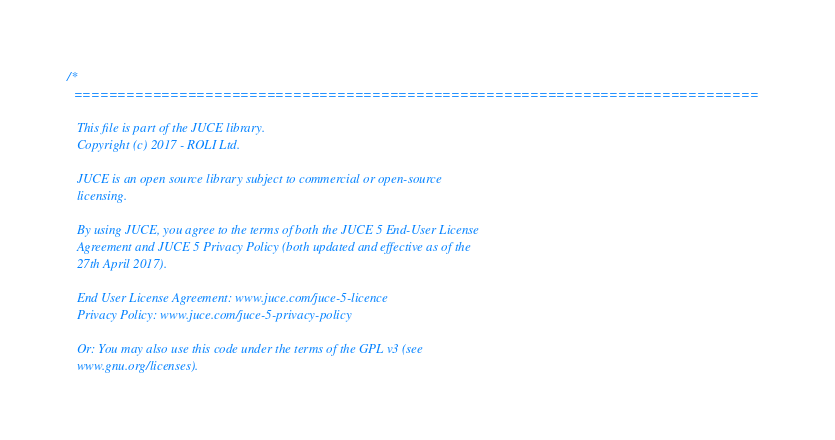<code> <loc_0><loc_0><loc_500><loc_500><_ObjectiveC_>/*
  ==============================================================================

   This file is part of the JUCE library.
   Copyright (c) 2017 - ROLI Ltd.

   JUCE is an open source library subject to commercial or open-source
   licensing.

   By using JUCE, you agree to the terms of both the JUCE 5 End-User License
   Agreement and JUCE 5 Privacy Policy (both updated and effective as of the
   27th April 2017).

   End User License Agreement: www.juce.com/juce-5-licence
   Privacy Policy: www.juce.com/juce-5-privacy-policy

   Or: You may also use this code under the terms of the GPL v3 (see
   www.gnu.org/licenses).
</code> 